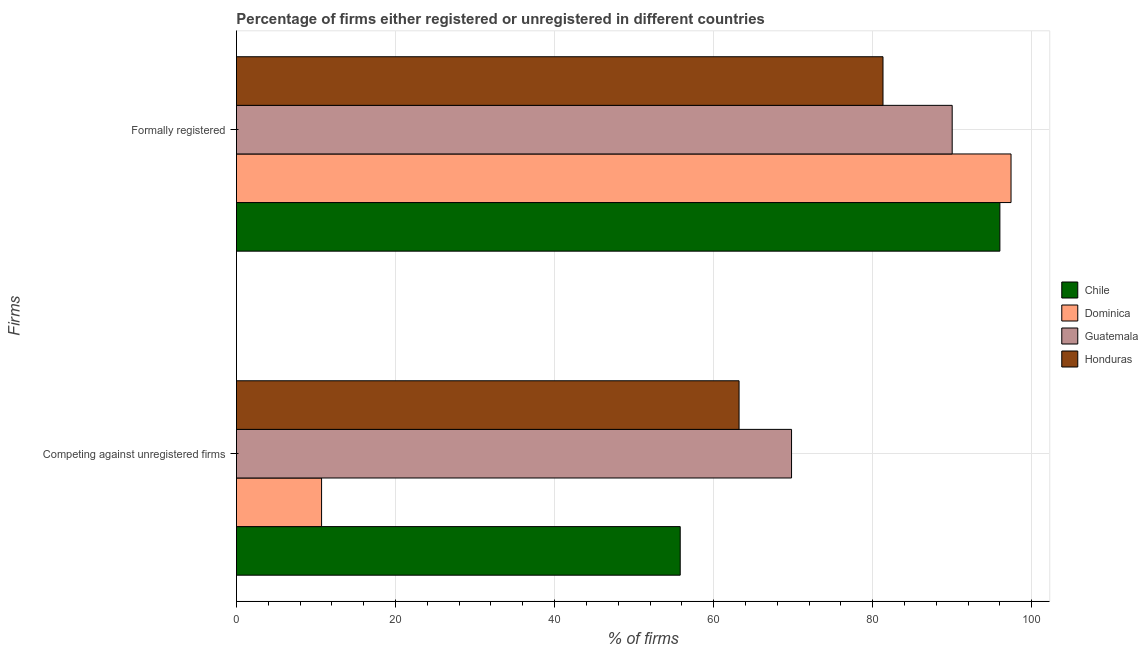How many bars are there on the 2nd tick from the top?
Make the answer very short. 4. How many bars are there on the 2nd tick from the bottom?
Make the answer very short. 4. What is the label of the 2nd group of bars from the top?
Make the answer very short. Competing against unregistered firms. Across all countries, what is the maximum percentage of registered firms?
Offer a very short reply. 69.8. Across all countries, what is the minimum percentage of registered firms?
Give a very brief answer. 10.7. In which country was the percentage of registered firms maximum?
Provide a succinct answer. Guatemala. In which country was the percentage of registered firms minimum?
Your answer should be very brief. Dominica. What is the total percentage of formally registered firms in the graph?
Your response must be concise. 364.7. What is the difference between the percentage of formally registered firms in Chile and that in Dominica?
Your answer should be very brief. -1.4. What is the difference between the percentage of registered firms in Chile and the percentage of formally registered firms in Dominica?
Provide a short and direct response. -41.6. What is the average percentage of registered firms per country?
Provide a short and direct response. 49.88. What is the difference between the percentage of formally registered firms and percentage of registered firms in Guatemala?
Ensure brevity in your answer.  20.2. What is the ratio of the percentage of registered firms in Honduras to that in Dominica?
Give a very brief answer. 5.91. Is the percentage of registered firms in Dominica less than that in Honduras?
Your answer should be very brief. Yes. In how many countries, is the percentage of registered firms greater than the average percentage of registered firms taken over all countries?
Your answer should be very brief. 3. What does the 3rd bar from the top in Formally registered represents?
Keep it short and to the point. Dominica. What does the 2nd bar from the bottom in Competing against unregistered firms represents?
Offer a very short reply. Dominica. How many bars are there?
Give a very brief answer. 8. Are all the bars in the graph horizontal?
Keep it short and to the point. Yes. What is the difference between two consecutive major ticks on the X-axis?
Ensure brevity in your answer.  20. Does the graph contain any zero values?
Keep it short and to the point. No. Where does the legend appear in the graph?
Provide a succinct answer. Center right. How many legend labels are there?
Your answer should be compact. 4. What is the title of the graph?
Keep it short and to the point. Percentage of firms either registered or unregistered in different countries. Does "Samoa" appear as one of the legend labels in the graph?
Your answer should be compact. No. What is the label or title of the X-axis?
Ensure brevity in your answer.  % of firms. What is the label or title of the Y-axis?
Your response must be concise. Firms. What is the % of firms in Chile in Competing against unregistered firms?
Your answer should be very brief. 55.8. What is the % of firms of Guatemala in Competing against unregistered firms?
Provide a succinct answer. 69.8. What is the % of firms in Honduras in Competing against unregistered firms?
Your answer should be compact. 63.2. What is the % of firms in Chile in Formally registered?
Keep it short and to the point. 96. What is the % of firms of Dominica in Formally registered?
Make the answer very short. 97.4. What is the % of firms in Guatemala in Formally registered?
Give a very brief answer. 90. What is the % of firms in Honduras in Formally registered?
Your answer should be compact. 81.3. Across all Firms, what is the maximum % of firms in Chile?
Your answer should be compact. 96. Across all Firms, what is the maximum % of firms in Dominica?
Keep it short and to the point. 97.4. Across all Firms, what is the maximum % of firms of Honduras?
Give a very brief answer. 81.3. Across all Firms, what is the minimum % of firms in Chile?
Keep it short and to the point. 55.8. Across all Firms, what is the minimum % of firms in Guatemala?
Keep it short and to the point. 69.8. Across all Firms, what is the minimum % of firms in Honduras?
Keep it short and to the point. 63.2. What is the total % of firms in Chile in the graph?
Your response must be concise. 151.8. What is the total % of firms in Dominica in the graph?
Offer a very short reply. 108.1. What is the total % of firms in Guatemala in the graph?
Your answer should be compact. 159.8. What is the total % of firms of Honduras in the graph?
Your answer should be very brief. 144.5. What is the difference between the % of firms in Chile in Competing against unregistered firms and that in Formally registered?
Give a very brief answer. -40.2. What is the difference between the % of firms of Dominica in Competing against unregistered firms and that in Formally registered?
Provide a succinct answer. -86.7. What is the difference between the % of firms of Guatemala in Competing against unregistered firms and that in Formally registered?
Provide a succinct answer. -20.2. What is the difference between the % of firms in Honduras in Competing against unregistered firms and that in Formally registered?
Provide a short and direct response. -18.1. What is the difference between the % of firms of Chile in Competing against unregistered firms and the % of firms of Dominica in Formally registered?
Your response must be concise. -41.6. What is the difference between the % of firms of Chile in Competing against unregistered firms and the % of firms of Guatemala in Formally registered?
Offer a very short reply. -34.2. What is the difference between the % of firms in Chile in Competing against unregistered firms and the % of firms in Honduras in Formally registered?
Keep it short and to the point. -25.5. What is the difference between the % of firms in Dominica in Competing against unregistered firms and the % of firms in Guatemala in Formally registered?
Give a very brief answer. -79.3. What is the difference between the % of firms of Dominica in Competing against unregistered firms and the % of firms of Honduras in Formally registered?
Provide a short and direct response. -70.6. What is the difference between the % of firms of Guatemala in Competing against unregistered firms and the % of firms of Honduras in Formally registered?
Provide a short and direct response. -11.5. What is the average % of firms in Chile per Firms?
Your answer should be very brief. 75.9. What is the average % of firms in Dominica per Firms?
Offer a terse response. 54.05. What is the average % of firms of Guatemala per Firms?
Provide a succinct answer. 79.9. What is the average % of firms of Honduras per Firms?
Offer a very short reply. 72.25. What is the difference between the % of firms in Chile and % of firms in Dominica in Competing against unregistered firms?
Keep it short and to the point. 45.1. What is the difference between the % of firms in Dominica and % of firms in Guatemala in Competing against unregistered firms?
Provide a short and direct response. -59.1. What is the difference between the % of firms of Dominica and % of firms of Honduras in Competing against unregistered firms?
Give a very brief answer. -52.5. What is the difference between the % of firms in Guatemala and % of firms in Honduras in Competing against unregistered firms?
Offer a very short reply. 6.6. What is the difference between the % of firms of Chile and % of firms of Dominica in Formally registered?
Your answer should be compact. -1.4. What is the difference between the % of firms of Guatemala and % of firms of Honduras in Formally registered?
Make the answer very short. 8.7. What is the ratio of the % of firms of Chile in Competing against unregistered firms to that in Formally registered?
Offer a very short reply. 0.58. What is the ratio of the % of firms of Dominica in Competing against unregistered firms to that in Formally registered?
Give a very brief answer. 0.11. What is the ratio of the % of firms of Guatemala in Competing against unregistered firms to that in Formally registered?
Provide a short and direct response. 0.78. What is the ratio of the % of firms in Honduras in Competing against unregistered firms to that in Formally registered?
Your answer should be compact. 0.78. What is the difference between the highest and the second highest % of firms of Chile?
Provide a short and direct response. 40.2. What is the difference between the highest and the second highest % of firms of Dominica?
Your response must be concise. 86.7. What is the difference between the highest and the second highest % of firms in Guatemala?
Offer a terse response. 20.2. What is the difference between the highest and the second highest % of firms of Honduras?
Offer a very short reply. 18.1. What is the difference between the highest and the lowest % of firms of Chile?
Provide a succinct answer. 40.2. What is the difference between the highest and the lowest % of firms in Dominica?
Offer a very short reply. 86.7. What is the difference between the highest and the lowest % of firms in Guatemala?
Keep it short and to the point. 20.2. 